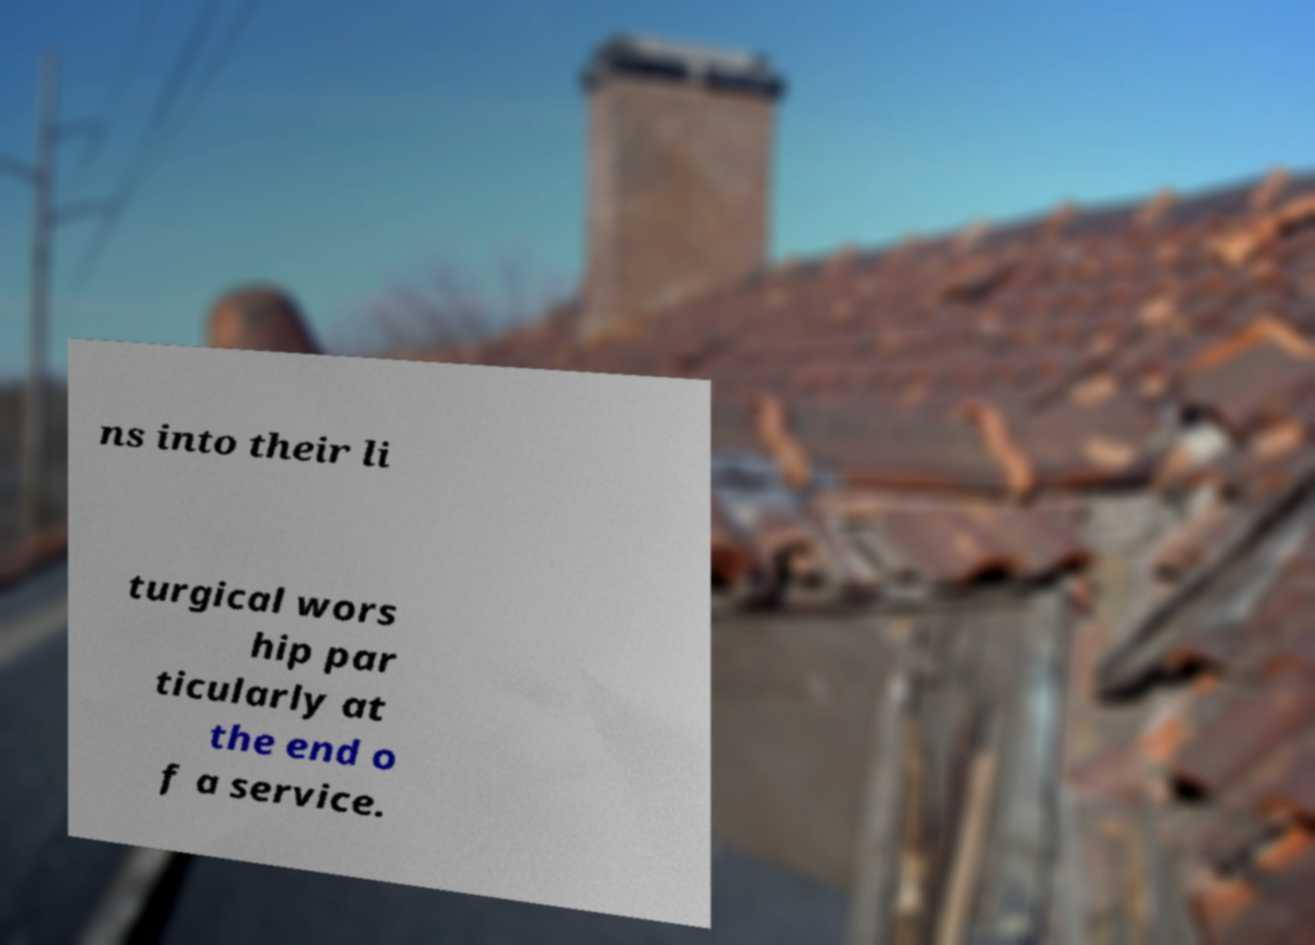Can you accurately transcribe the text from the provided image for me? ns into their li turgical wors hip par ticularly at the end o f a service. 